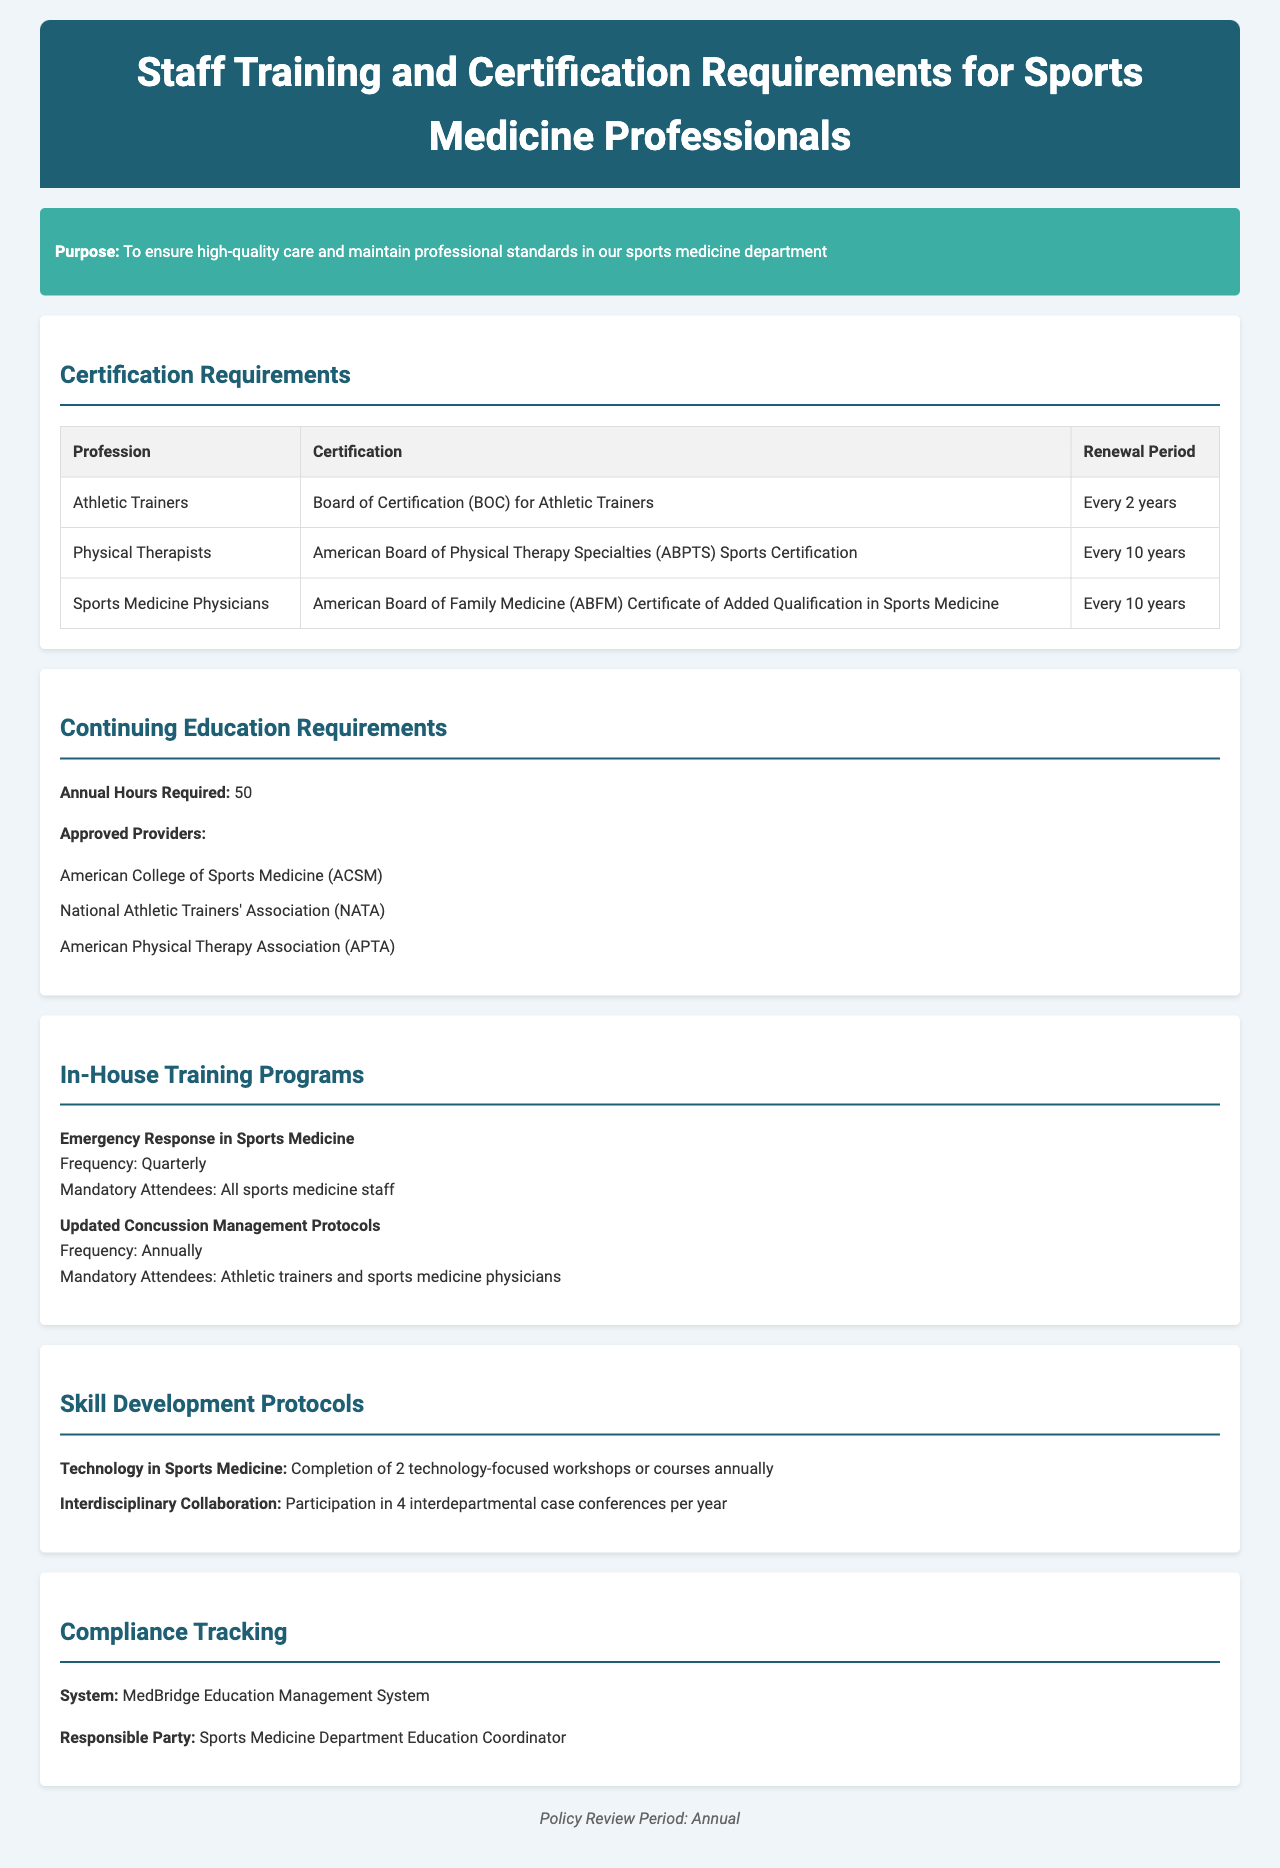What is the renewal period for Athletic Trainers' certification? The renewal period for Athletic Trainers' certification is every 2 years, as stated in the certification requirements table.
Answer: Every 2 years How many annual hours of continuing education are required? According to the continuing education requirements section, the number of annual hours required is specified clearly.
Answer: 50 Which organization is an approved provider for continuing education? The document lists several approved providers; one example is enough to answer this question.
Answer: American College of Sports Medicine How often are the in-house training programs held? The frequency of the in-house training program 'Emergency Response in Sports Medicine' is mentioned explicitly in the document.
Answer: Quarterly What is the responsible party for compliance tracking? The document specifies the responsible party for compliance tracking in the compliance tracking section.
Answer: Sports Medicine Department Education Coordinator What is the focus of skill development protocols? The skill development protocols section outlines specific areas of focus for skill development.
Answer: Technology in Sports Medicine Which certification do Sports Medicine Physicians require? The certification requirements table includes the required certification for Sports Medicine Physicians.
Answer: American Board of Family Medicine Certificate of Added Qualification in Sports Medicine How many interdepartmental case conferences must be attended per year? The skill development protocols section states the required participation in interdepartmental case conferences annually.
Answer: 4 